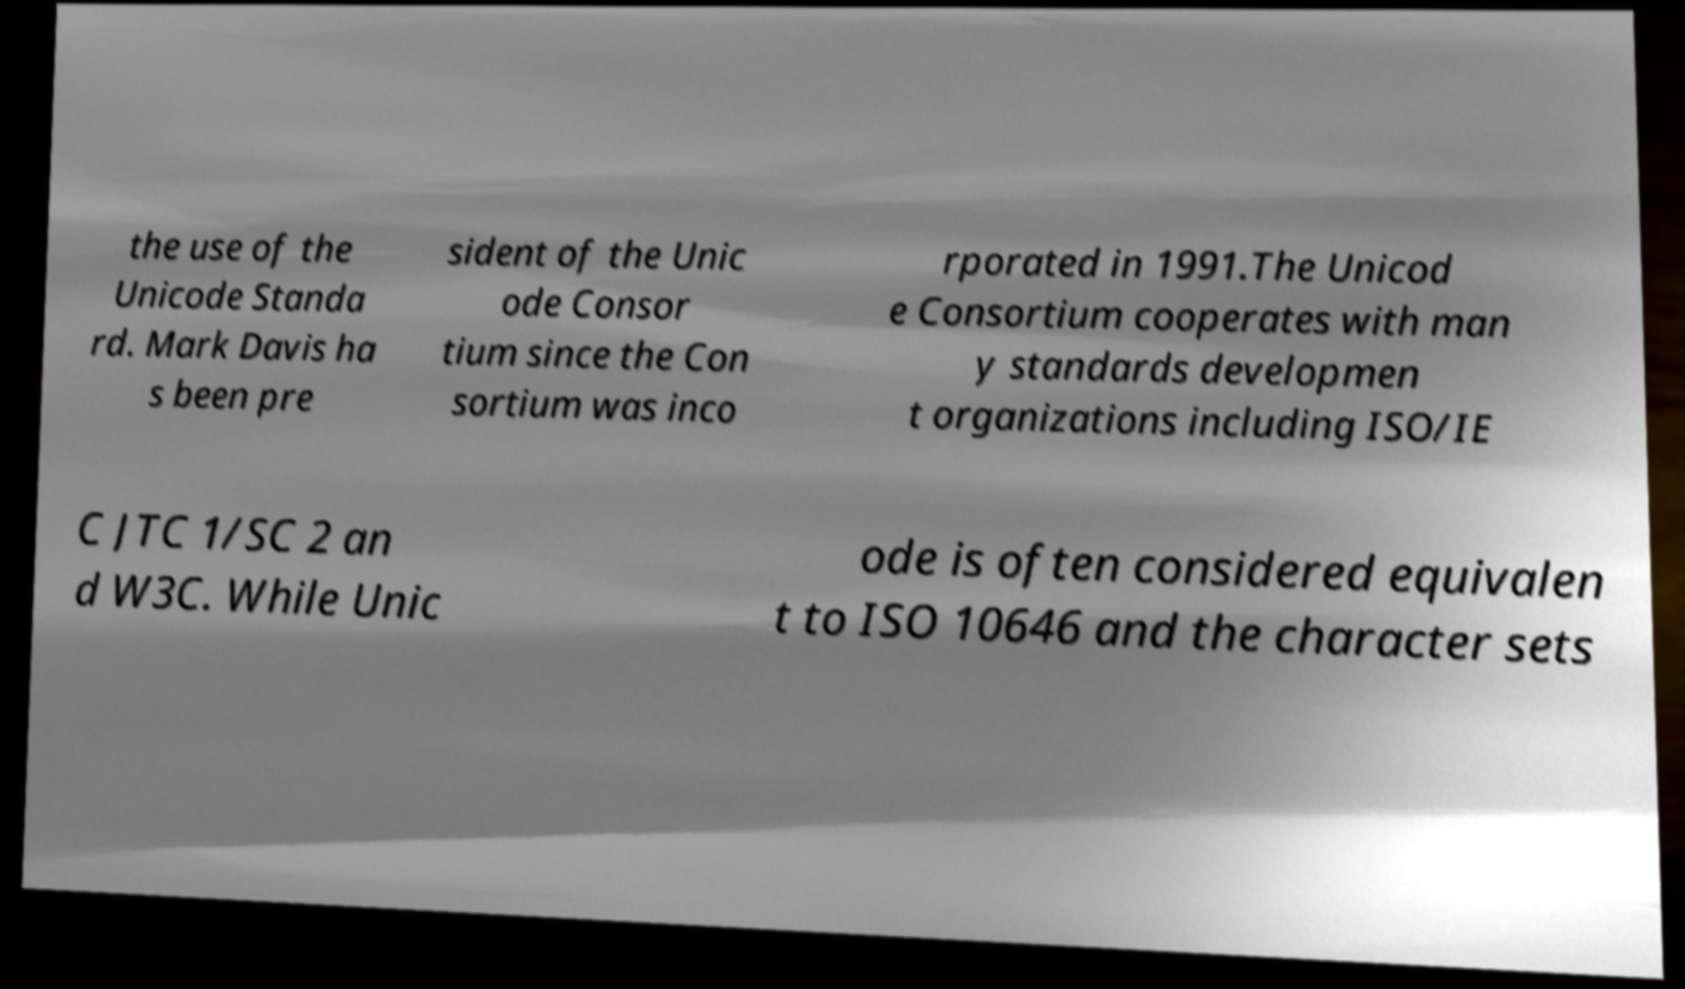What messages or text are displayed in this image? I need them in a readable, typed format. the use of the Unicode Standa rd. Mark Davis ha s been pre sident of the Unic ode Consor tium since the Con sortium was inco rporated in 1991.The Unicod e Consortium cooperates with man y standards developmen t organizations including ISO/IE C JTC 1/SC 2 an d W3C. While Unic ode is often considered equivalen t to ISO 10646 and the character sets 